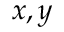<formula> <loc_0><loc_0><loc_500><loc_500>x , y</formula> 